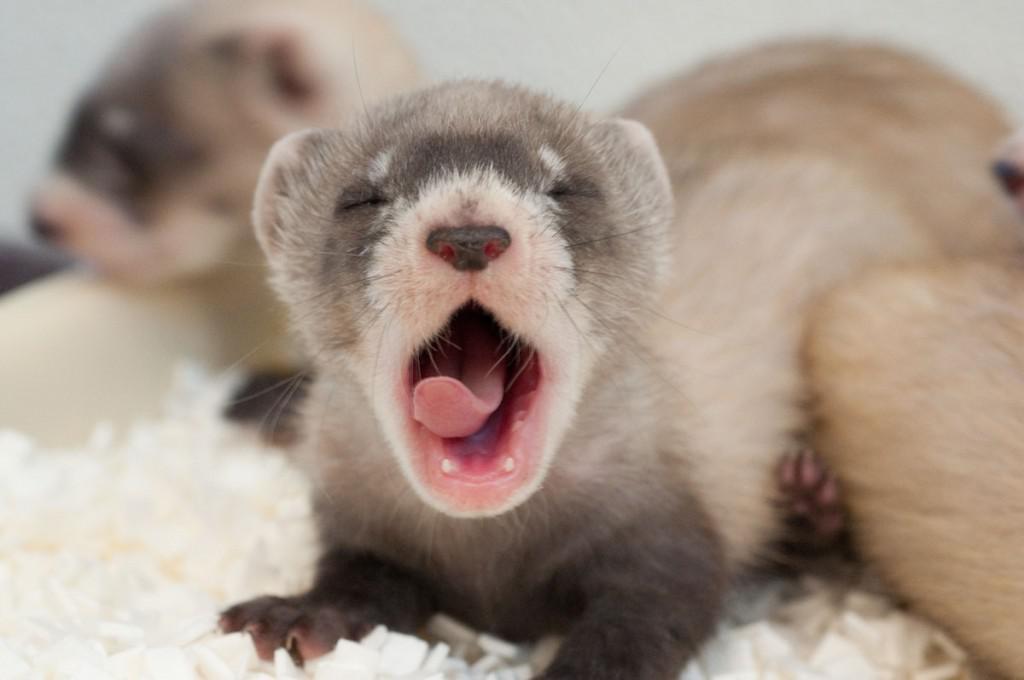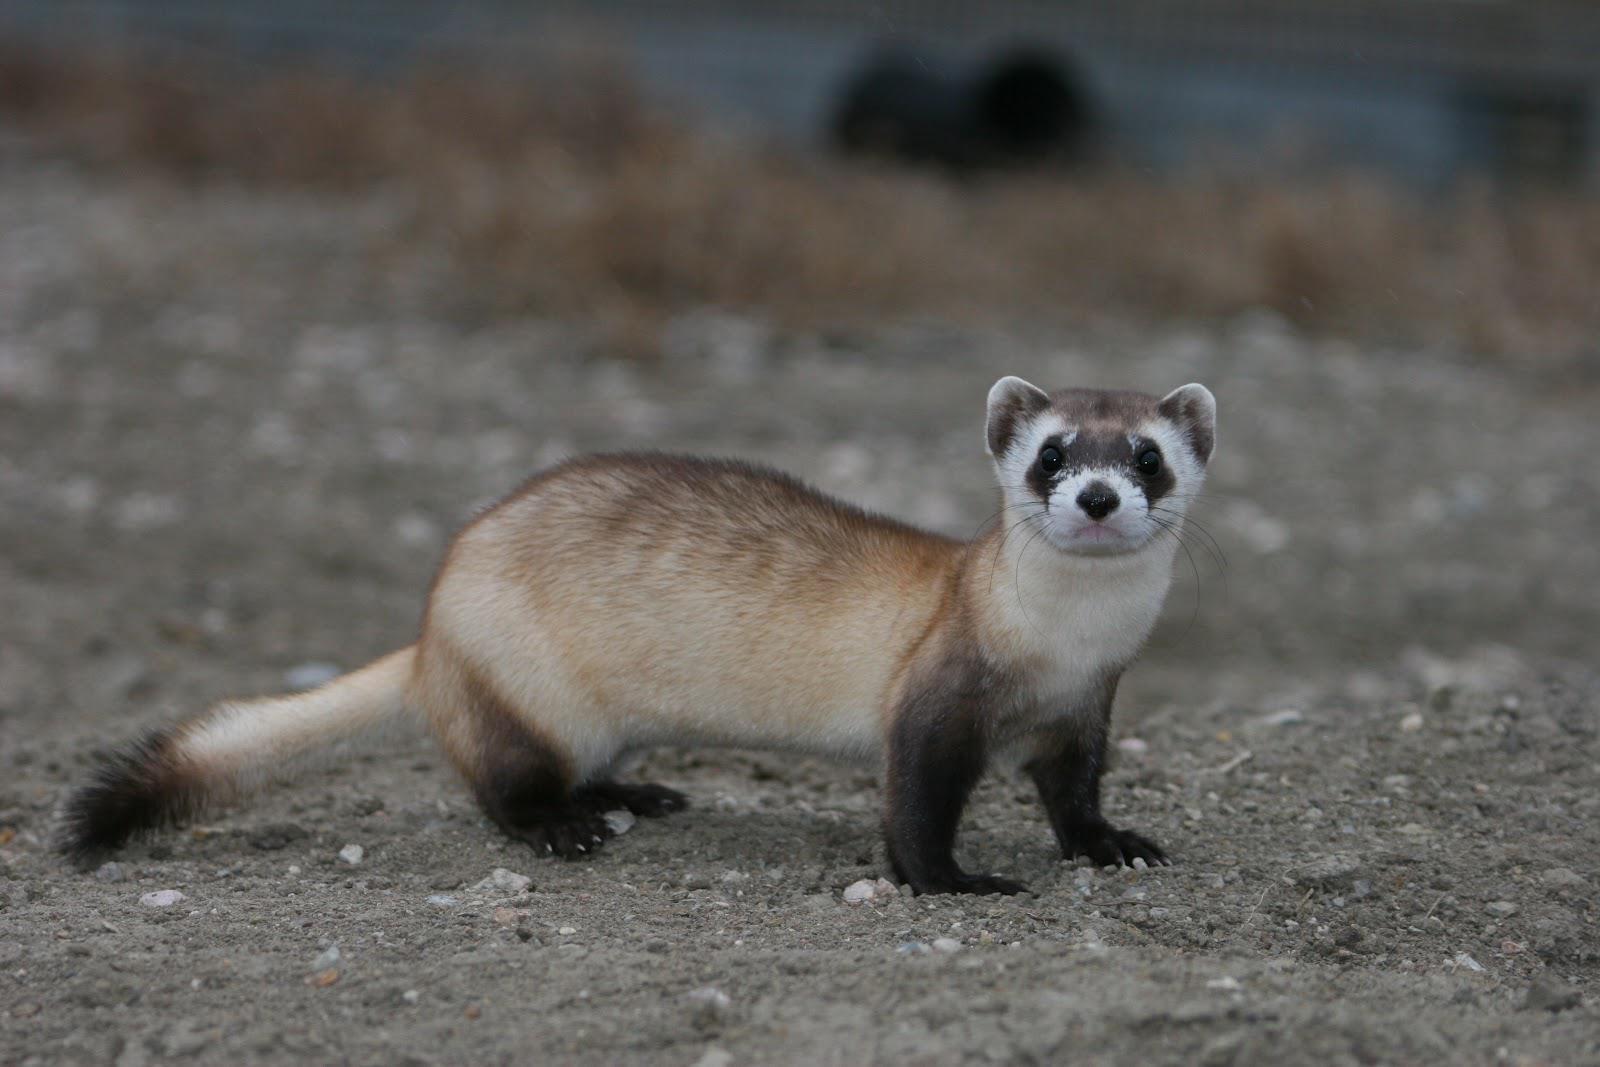The first image is the image on the left, the second image is the image on the right. For the images displayed, is the sentence "There are exactly five ferrets in the left image." factually correct? Answer yes or no. No. The first image is the image on the left, the second image is the image on the right. For the images displayed, is the sentence "There are three ferrets" factually correct? Answer yes or no. Yes. 